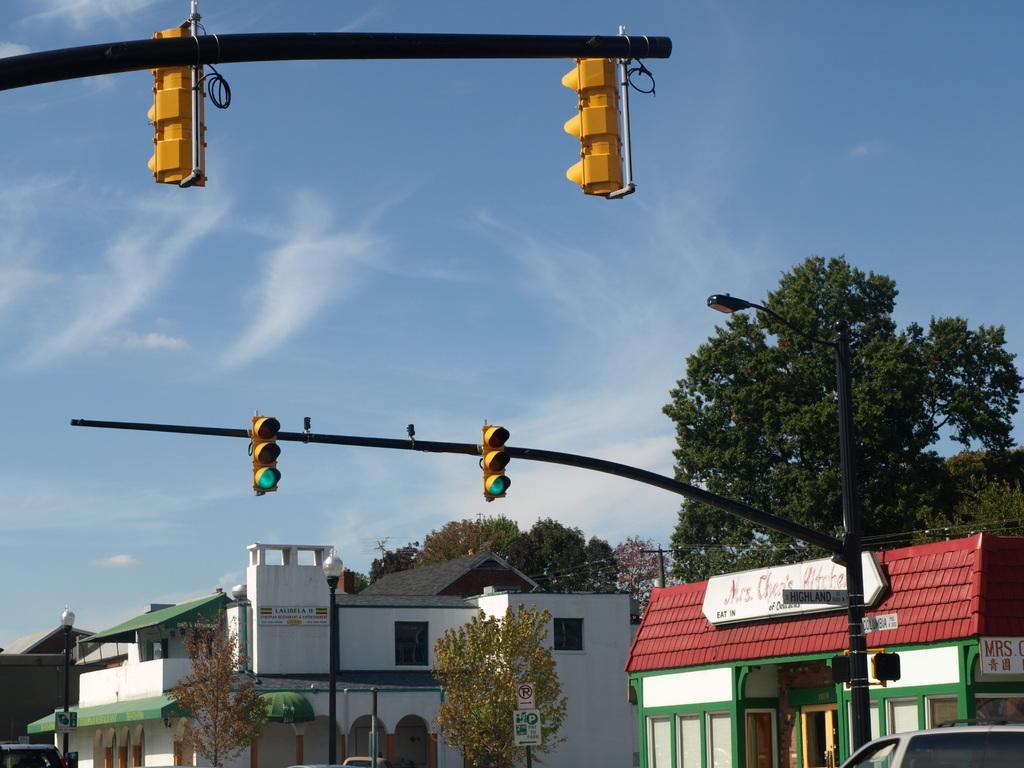Could you give a brief overview of what you see in this image? In the foreground of this image, there are traffic poles and at the bottom left and right, it seems like vehicle. In the background, there are trees and building. At the top, there is the sky. 